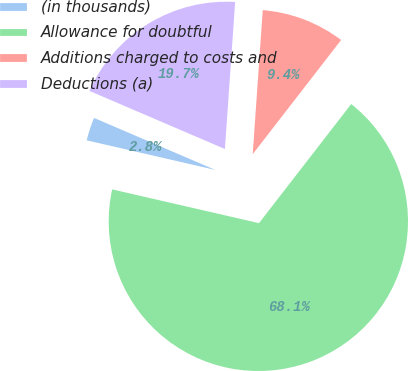Convert chart to OTSL. <chart><loc_0><loc_0><loc_500><loc_500><pie_chart><fcel>(in thousands)<fcel>Allowance for doubtful<fcel>Additions charged to costs and<fcel>Deductions (a)<nl><fcel>2.85%<fcel>68.11%<fcel>9.38%<fcel>19.66%<nl></chart> 